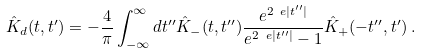<formula> <loc_0><loc_0><loc_500><loc_500>\hat { K } _ { d } ( t , t ^ { \prime } ) = - \frac { 4 } { \pi } \int _ { - \infty } ^ { \infty } d t ^ { \prime \prime } \hat { K } _ { - } ( t , t ^ { \prime \prime } ) \frac { e ^ { 2 \ e | t ^ { \prime \prime } | } } { e ^ { 2 \ e | t ^ { \prime \prime } | } - 1 } \hat { K } _ { + } ( - t ^ { \prime \prime } , t ^ { \prime } ) \, .</formula> 